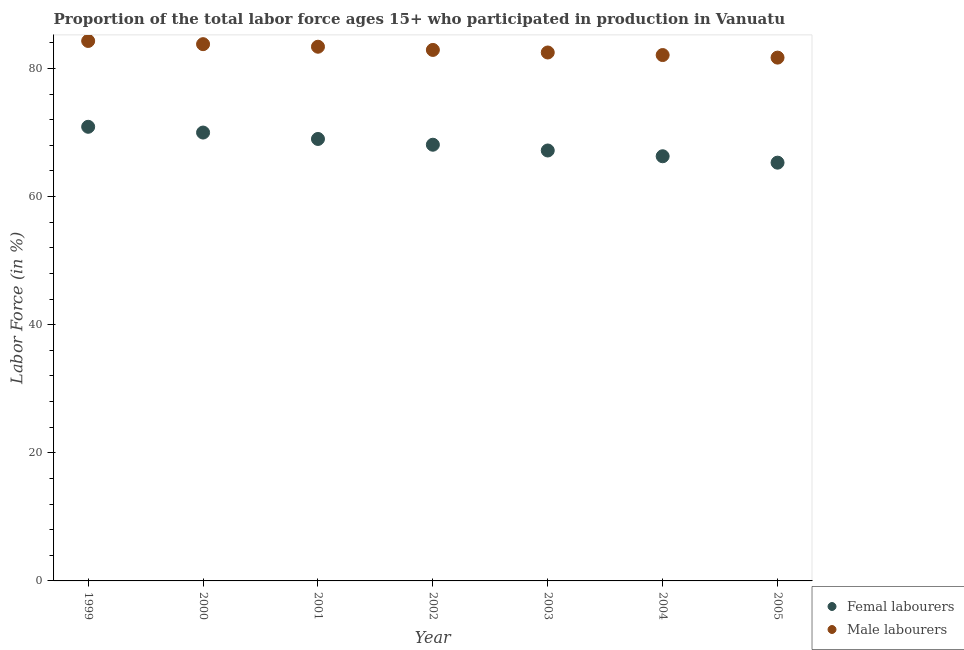Is the number of dotlines equal to the number of legend labels?
Keep it short and to the point. Yes. What is the percentage of female labor force in 2005?
Ensure brevity in your answer.  65.3. Across all years, what is the maximum percentage of female labor force?
Your answer should be compact. 70.9. Across all years, what is the minimum percentage of male labour force?
Keep it short and to the point. 81.7. In which year was the percentage of female labor force maximum?
Your answer should be compact. 1999. In which year was the percentage of male labour force minimum?
Ensure brevity in your answer.  2005. What is the total percentage of male labour force in the graph?
Make the answer very short. 580.7. What is the difference between the percentage of male labour force in 2003 and that in 2004?
Your answer should be compact. 0.4. What is the difference between the percentage of male labour force in 2003 and the percentage of female labor force in 2005?
Offer a terse response. 17.2. What is the average percentage of female labor force per year?
Offer a terse response. 68.11. In the year 2000, what is the difference between the percentage of female labor force and percentage of male labour force?
Ensure brevity in your answer.  -13.8. What is the ratio of the percentage of male labour force in 1999 to that in 2005?
Offer a terse response. 1.03. Is the percentage of male labour force in 2002 less than that in 2005?
Offer a terse response. No. Is the difference between the percentage of male labour force in 1999 and 2005 greater than the difference between the percentage of female labor force in 1999 and 2005?
Keep it short and to the point. No. What is the difference between the highest and the second highest percentage of female labor force?
Offer a terse response. 0.9. What is the difference between the highest and the lowest percentage of male labour force?
Ensure brevity in your answer.  2.6. Is the percentage of female labor force strictly greater than the percentage of male labour force over the years?
Offer a terse response. No. How many dotlines are there?
Offer a very short reply. 2. What is the difference between two consecutive major ticks on the Y-axis?
Make the answer very short. 20. Are the values on the major ticks of Y-axis written in scientific E-notation?
Provide a succinct answer. No. Does the graph contain any zero values?
Make the answer very short. No. Where does the legend appear in the graph?
Offer a terse response. Bottom right. How are the legend labels stacked?
Give a very brief answer. Vertical. What is the title of the graph?
Ensure brevity in your answer.  Proportion of the total labor force ages 15+ who participated in production in Vanuatu. Does "Grants" appear as one of the legend labels in the graph?
Your answer should be compact. No. What is the label or title of the Y-axis?
Provide a short and direct response. Labor Force (in %). What is the Labor Force (in %) of Femal labourers in 1999?
Your answer should be very brief. 70.9. What is the Labor Force (in %) of Male labourers in 1999?
Give a very brief answer. 84.3. What is the Labor Force (in %) of Femal labourers in 2000?
Offer a terse response. 70. What is the Labor Force (in %) in Male labourers in 2000?
Offer a very short reply. 83.8. What is the Labor Force (in %) in Male labourers in 2001?
Your response must be concise. 83.4. What is the Labor Force (in %) in Femal labourers in 2002?
Your answer should be very brief. 68.1. What is the Labor Force (in %) in Male labourers in 2002?
Ensure brevity in your answer.  82.9. What is the Labor Force (in %) in Femal labourers in 2003?
Your answer should be compact. 67.2. What is the Labor Force (in %) of Male labourers in 2003?
Make the answer very short. 82.5. What is the Labor Force (in %) of Femal labourers in 2004?
Your response must be concise. 66.3. What is the Labor Force (in %) of Male labourers in 2004?
Provide a short and direct response. 82.1. What is the Labor Force (in %) in Femal labourers in 2005?
Offer a very short reply. 65.3. What is the Labor Force (in %) in Male labourers in 2005?
Your answer should be very brief. 81.7. Across all years, what is the maximum Labor Force (in %) in Femal labourers?
Offer a very short reply. 70.9. Across all years, what is the maximum Labor Force (in %) in Male labourers?
Provide a succinct answer. 84.3. Across all years, what is the minimum Labor Force (in %) of Femal labourers?
Your answer should be very brief. 65.3. Across all years, what is the minimum Labor Force (in %) of Male labourers?
Give a very brief answer. 81.7. What is the total Labor Force (in %) in Femal labourers in the graph?
Ensure brevity in your answer.  476.8. What is the total Labor Force (in %) of Male labourers in the graph?
Provide a short and direct response. 580.7. What is the difference between the Labor Force (in %) in Male labourers in 1999 and that in 2000?
Keep it short and to the point. 0.5. What is the difference between the Labor Force (in %) in Femal labourers in 1999 and that in 2001?
Keep it short and to the point. 1.9. What is the difference between the Labor Force (in %) in Male labourers in 1999 and that in 2001?
Provide a succinct answer. 0.9. What is the difference between the Labor Force (in %) in Femal labourers in 1999 and that in 2002?
Offer a very short reply. 2.8. What is the difference between the Labor Force (in %) of Male labourers in 1999 and that in 2002?
Your response must be concise. 1.4. What is the difference between the Labor Force (in %) in Femal labourers in 1999 and that in 2003?
Provide a short and direct response. 3.7. What is the difference between the Labor Force (in %) in Male labourers in 1999 and that in 2003?
Your response must be concise. 1.8. What is the difference between the Labor Force (in %) of Femal labourers in 1999 and that in 2004?
Your answer should be very brief. 4.6. What is the difference between the Labor Force (in %) in Male labourers in 1999 and that in 2004?
Offer a very short reply. 2.2. What is the difference between the Labor Force (in %) in Femal labourers in 1999 and that in 2005?
Give a very brief answer. 5.6. What is the difference between the Labor Force (in %) in Femal labourers in 2000 and that in 2002?
Offer a terse response. 1.9. What is the difference between the Labor Force (in %) in Femal labourers in 2000 and that in 2003?
Provide a short and direct response. 2.8. What is the difference between the Labor Force (in %) in Femal labourers in 2000 and that in 2004?
Your response must be concise. 3.7. What is the difference between the Labor Force (in %) of Femal labourers in 2000 and that in 2005?
Make the answer very short. 4.7. What is the difference between the Labor Force (in %) in Male labourers in 2000 and that in 2005?
Offer a terse response. 2.1. What is the difference between the Labor Force (in %) of Femal labourers in 2001 and that in 2003?
Give a very brief answer. 1.8. What is the difference between the Labor Force (in %) in Femal labourers in 2001 and that in 2004?
Make the answer very short. 2.7. What is the difference between the Labor Force (in %) of Male labourers in 2001 and that in 2004?
Your answer should be compact. 1.3. What is the difference between the Labor Force (in %) of Femal labourers in 2001 and that in 2005?
Ensure brevity in your answer.  3.7. What is the difference between the Labor Force (in %) of Femal labourers in 2002 and that in 2003?
Your answer should be very brief. 0.9. What is the difference between the Labor Force (in %) in Male labourers in 2002 and that in 2003?
Make the answer very short. 0.4. What is the difference between the Labor Force (in %) of Femal labourers in 2002 and that in 2004?
Your answer should be compact. 1.8. What is the difference between the Labor Force (in %) of Femal labourers in 2004 and that in 2005?
Make the answer very short. 1. What is the difference between the Labor Force (in %) of Femal labourers in 1999 and the Labor Force (in %) of Male labourers in 2000?
Give a very brief answer. -12.9. What is the difference between the Labor Force (in %) of Femal labourers in 1999 and the Labor Force (in %) of Male labourers in 2002?
Offer a very short reply. -12. What is the difference between the Labor Force (in %) in Femal labourers in 1999 and the Labor Force (in %) in Male labourers in 2005?
Your answer should be very brief. -10.8. What is the difference between the Labor Force (in %) in Femal labourers in 2000 and the Labor Force (in %) in Male labourers in 2003?
Offer a very short reply. -12.5. What is the difference between the Labor Force (in %) in Femal labourers in 2000 and the Labor Force (in %) in Male labourers in 2004?
Ensure brevity in your answer.  -12.1. What is the difference between the Labor Force (in %) of Femal labourers in 2000 and the Labor Force (in %) of Male labourers in 2005?
Provide a succinct answer. -11.7. What is the difference between the Labor Force (in %) of Femal labourers in 2002 and the Labor Force (in %) of Male labourers in 2003?
Make the answer very short. -14.4. What is the difference between the Labor Force (in %) in Femal labourers in 2003 and the Labor Force (in %) in Male labourers in 2004?
Your answer should be compact. -14.9. What is the difference between the Labor Force (in %) in Femal labourers in 2003 and the Labor Force (in %) in Male labourers in 2005?
Offer a very short reply. -14.5. What is the difference between the Labor Force (in %) in Femal labourers in 2004 and the Labor Force (in %) in Male labourers in 2005?
Provide a succinct answer. -15.4. What is the average Labor Force (in %) of Femal labourers per year?
Offer a very short reply. 68.11. What is the average Labor Force (in %) in Male labourers per year?
Offer a terse response. 82.96. In the year 1999, what is the difference between the Labor Force (in %) of Femal labourers and Labor Force (in %) of Male labourers?
Provide a succinct answer. -13.4. In the year 2000, what is the difference between the Labor Force (in %) of Femal labourers and Labor Force (in %) of Male labourers?
Provide a succinct answer. -13.8. In the year 2001, what is the difference between the Labor Force (in %) of Femal labourers and Labor Force (in %) of Male labourers?
Keep it short and to the point. -14.4. In the year 2002, what is the difference between the Labor Force (in %) in Femal labourers and Labor Force (in %) in Male labourers?
Give a very brief answer. -14.8. In the year 2003, what is the difference between the Labor Force (in %) in Femal labourers and Labor Force (in %) in Male labourers?
Provide a short and direct response. -15.3. In the year 2004, what is the difference between the Labor Force (in %) in Femal labourers and Labor Force (in %) in Male labourers?
Offer a very short reply. -15.8. In the year 2005, what is the difference between the Labor Force (in %) of Femal labourers and Labor Force (in %) of Male labourers?
Your answer should be very brief. -16.4. What is the ratio of the Labor Force (in %) of Femal labourers in 1999 to that in 2000?
Make the answer very short. 1.01. What is the ratio of the Labor Force (in %) in Male labourers in 1999 to that in 2000?
Offer a very short reply. 1.01. What is the ratio of the Labor Force (in %) of Femal labourers in 1999 to that in 2001?
Your answer should be very brief. 1.03. What is the ratio of the Labor Force (in %) of Male labourers in 1999 to that in 2001?
Ensure brevity in your answer.  1.01. What is the ratio of the Labor Force (in %) of Femal labourers in 1999 to that in 2002?
Offer a terse response. 1.04. What is the ratio of the Labor Force (in %) in Male labourers in 1999 to that in 2002?
Your response must be concise. 1.02. What is the ratio of the Labor Force (in %) in Femal labourers in 1999 to that in 2003?
Offer a very short reply. 1.06. What is the ratio of the Labor Force (in %) of Male labourers in 1999 to that in 2003?
Ensure brevity in your answer.  1.02. What is the ratio of the Labor Force (in %) of Femal labourers in 1999 to that in 2004?
Ensure brevity in your answer.  1.07. What is the ratio of the Labor Force (in %) in Male labourers in 1999 to that in 2004?
Give a very brief answer. 1.03. What is the ratio of the Labor Force (in %) in Femal labourers in 1999 to that in 2005?
Your answer should be compact. 1.09. What is the ratio of the Labor Force (in %) in Male labourers in 1999 to that in 2005?
Ensure brevity in your answer.  1.03. What is the ratio of the Labor Force (in %) in Femal labourers in 2000 to that in 2001?
Make the answer very short. 1.01. What is the ratio of the Labor Force (in %) of Femal labourers in 2000 to that in 2002?
Give a very brief answer. 1.03. What is the ratio of the Labor Force (in %) in Male labourers in 2000 to that in 2002?
Offer a very short reply. 1.01. What is the ratio of the Labor Force (in %) in Femal labourers in 2000 to that in 2003?
Your response must be concise. 1.04. What is the ratio of the Labor Force (in %) of Male labourers in 2000 to that in 2003?
Your answer should be very brief. 1.02. What is the ratio of the Labor Force (in %) of Femal labourers in 2000 to that in 2004?
Provide a succinct answer. 1.06. What is the ratio of the Labor Force (in %) in Male labourers in 2000 to that in 2004?
Your answer should be compact. 1.02. What is the ratio of the Labor Force (in %) in Femal labourers in 2000 to that in 2005?
Provide a succinct answer. 1.07. What is the ratio of the Labor Force (in %) in Male labourers in 2000 to that in 2005?
Your response must be concise. 1.03. What is the ratio of the Labor Force (in %) of Femal labourers in 2001 to that in 2002?
Your response must be concise. 1.01. What is the ratio of the Labor Force (in %) of Femal labourers in 2001 to that in 2003?
Offer a terse response. 1.03. What is the ratio of the Labor Force (in %) of Male labourers in 2001 to that in 2003?
Give a very brief answer. 1.01. What is the ratio of the Labor Force (in %) of Femal labourers in 2001 to that in 2004?
Ensure brevity in your answer.  1.04. What is the ratio of the Labor Force (in %) of Male labourers in 2001 to that in 2004?
Ensure brevity in your answer.  1.02. What is the ratio of the Labor Force (in %) in Femal labourers in 2001 to that in 2005?
Your answer should be compact. 1.06. What is the ratio of the Labor Force (in %) in Male labourers in 2001 to that in 2005?
Provide a succinct answer. 1.02. What is the ratio of the Labor Force (in %) in Femal labourers in 2002 to that in 2003?
Offer a very short reply. 1.01. What is the ratio of the Labor Force (in %) in Male labourers in 2002 to that in 2003?
Provide a short and direct response. 1. What is the ratio of the Labor Force (in %) of Femal labourers in 2002 to that in 2004?
Offer a terse response. 1.03. What is the ratio of the Labor Force (in %) of Male labourers in 2002 to that in 2004?
Your answer should be very brief. 1.01. What is the ratio of the Labor Force (in %) of Femal labourers in 2002 to that in 2005?
Your answer should be compact. 1.04. What is the ratio of the Labor Force (in %) of Male labourers in 2002 to that in 2005?
Offer a terse response. 1.01. What is the ratio of the Labor Force (in %) of Femal labourers in 2003 to that in 2004?
Offer a very short reply. 1.01. What is the ratio of the Labor Force (in %) of Femal labourers in 2003 to that in 2005?
Give a very brief answer. 1.03. What is the ratio of the Labor Force (in %) in Male labourers in 2003 to that in 2005?
Make the answer very short. 1.01. What is the ratio of the Labor Force (in %) in Femal labourers in 2004 to that in 2005?
Give a very brief answer. 1.02. What is the ratio of the Labor Force (in %) of Male labourers in 2004 to that in 2005?
Provide a short and direct response. 1. What is the difference between the highest and the second highest Labor Force (in %) in Femal labourers?
Offer a terse response. 0.9. What is the difference between the highest and the second highest Labor Force (in %) in Male labourers?
Give a very brief answer. 0.5. 